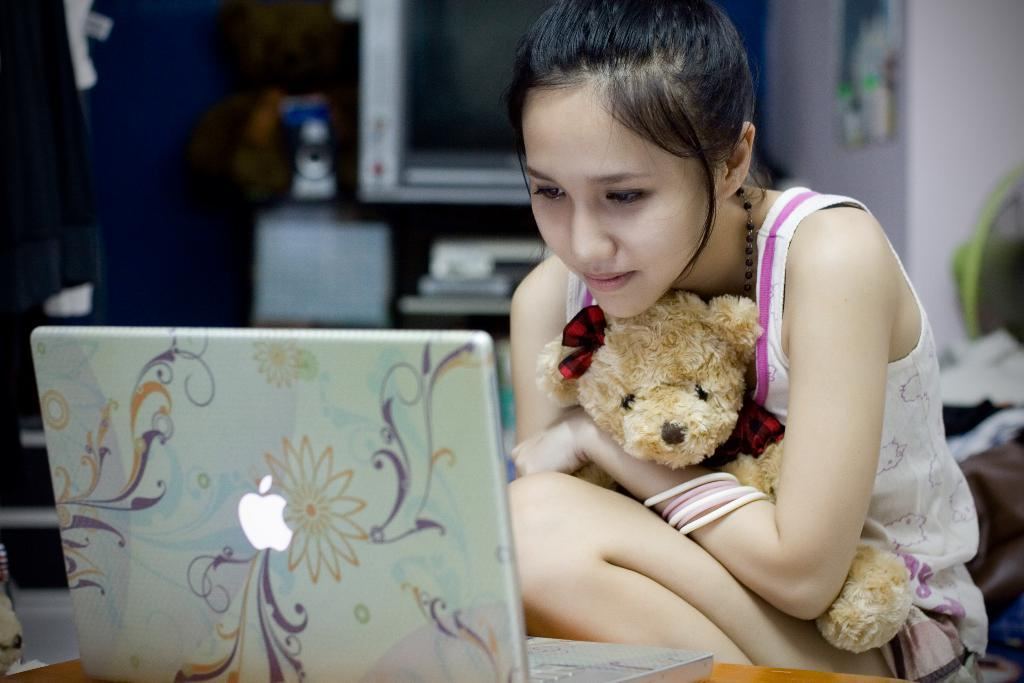Who is the main subject in the image? There is a girl in the image. What is the girl holding in the image? The girl is holding a teddy bear. What electronic device is in front of the girl? There is a laptop in front of the girl. Can you describe the background of the image? There are objects visible in the background of the image. What type of rice can be seen in the image? There is no rice present in the image. Is there a tub visible in the image? There is no tub present in the image. 